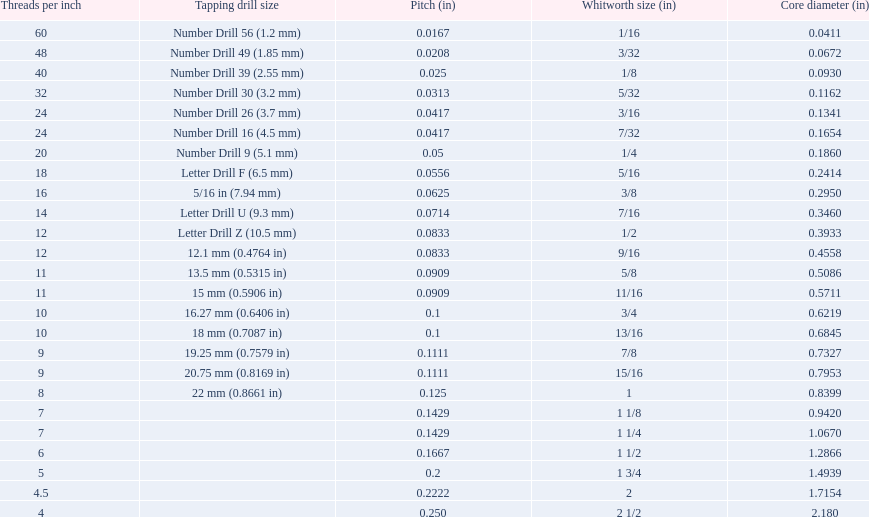What is the core diameter for the number drill 26? 0.1341. What is the whitworth size (in) for this core diameter? 3/16. Can you parse all the data within this table? {'header': ['Threads per\xa0inch', 'Tapping drill size', 'Pitch (in)', 'Whitworth size (in)', 'Core diameter (in)'], 'rows': [['60', 'Number Drill 56 (1.2\xa0mm)', '0.0167', '1/16', '0.0411'], ['48', 'Number Drill 49 (1.85\xa0mm)', '0.0208', '3/32', '0.0672'], ['40', 'Number Drill 39 (2.55\xa0mm)', '0.025', '1/8', '0.0930'], ['32', 'Number Drill 30 (3.2\xa0mm)', '0.0313', '5/32', '0.1162'], ['24', 'Number Drill 26 (3.7\xa0mm)', '0.0417', '3/16', '0.1341'], ['24', 'Number Drill 16 (4.5\xa0mm)', '0.0417', '7/32', '0.1654'], ['20', 'Number Drill 9 (5.1\xa0mm)', '0.05', '1/4', '0.1860'], ['18', 'Letter Drill F (6.5\xa0mm)', '0.0556', '5/16', '0.2414'], ['16', '5/16\xa0in (7.94\xa0mm)', '0.0625', '3/8', '0.2950'], ['14', 'Letter Drill U (9.3\xa0mm)', '0.0714', '7/16', '0.3460'], ['12', 'Letter Drill Z (10.5\xa0mm)', '0.0833', '1/2', '0.3933'], ['12', '12.1\xa0mm (0.4764\xa0in)', '0.0833', '9/16', '0.4558'], ['11', '13.5\xa0mm (0.5315\xa0in)', '0.0909', '5/8', '0.5086'], ['11', '15\xa0mm (0.5906\xa0in)', '0.0909', '11/16', '0.5711'], ['10', '16.27\xa0mm (0.6406\xa0in)', '0.1', '3/4', '0.6219'], ['10', '18\xa0mm (0.7087\xa0in)', '0.1', '13/16', '0.6845'], ['9', '19.25\xa0mm (0.7579\xa0in)', '0.1111', '7/8', '0.7327'], ['9', '20.75\xa0mm (0.8169\xa0in)', '0.1111', '15/16', '0.7953'], ['8', '22\xa0mm (0.8661\xa0in)', '0.125', '1', '0.8399'], ['7', '', '0.1429', '1 1/8', '0.9420'], ['7', '', '0.1429', '1 1/4', '1.0670'], ['6', '', '0.1667', '1 1/2', '1.2866'], ['5', '', '0.2', '1 3/4', '1.4939'], ['4.5', '', '0.2222', '2', '1.7154'], ['4', '', '0.250', '2 1/2', '2.180']]} 